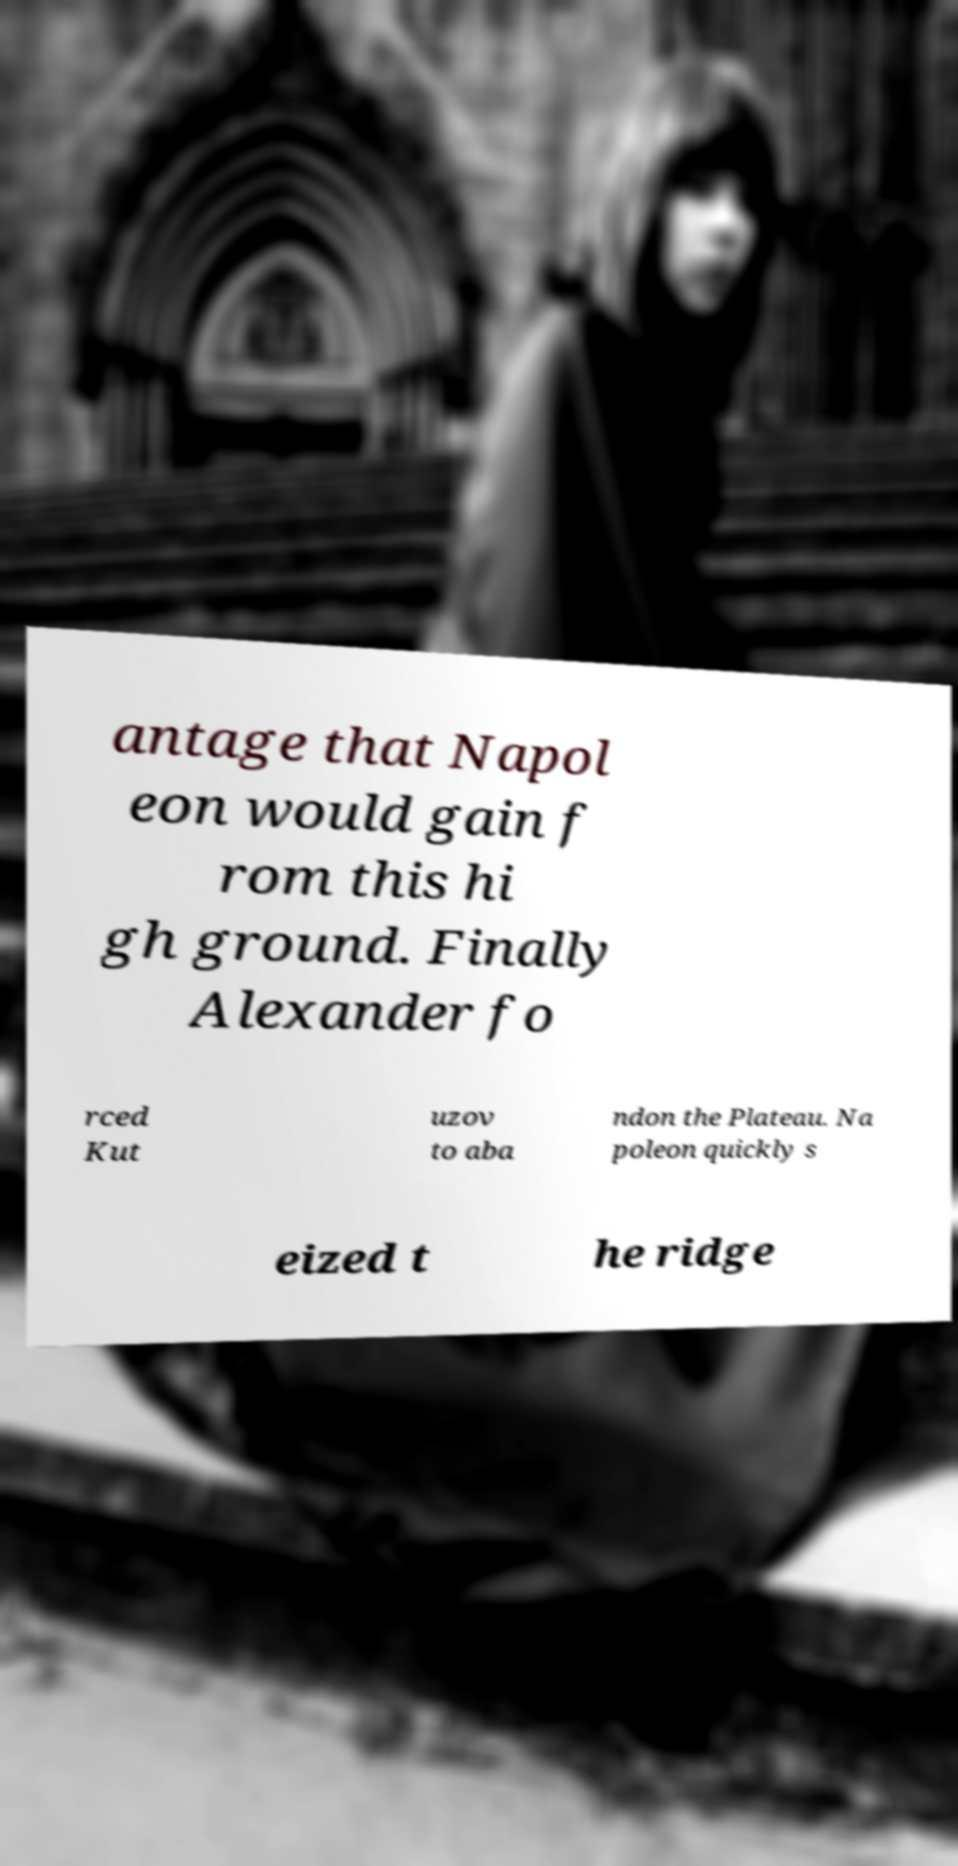Can you read and provide the text displayed in the image?This photo seems to have some interesting text. Can you extract and type it out for me? antage that Napol eon would gain f rom this hi gh ground. Finally Alexander fo rced Kut uzov to aba ndon the Plateau. Na poleon quickly s eized t he ridge 